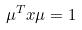<formula> <loc_0><loc_0><loc_500><loc_500>\mu ^ { T } x \mu = 1</formula> 